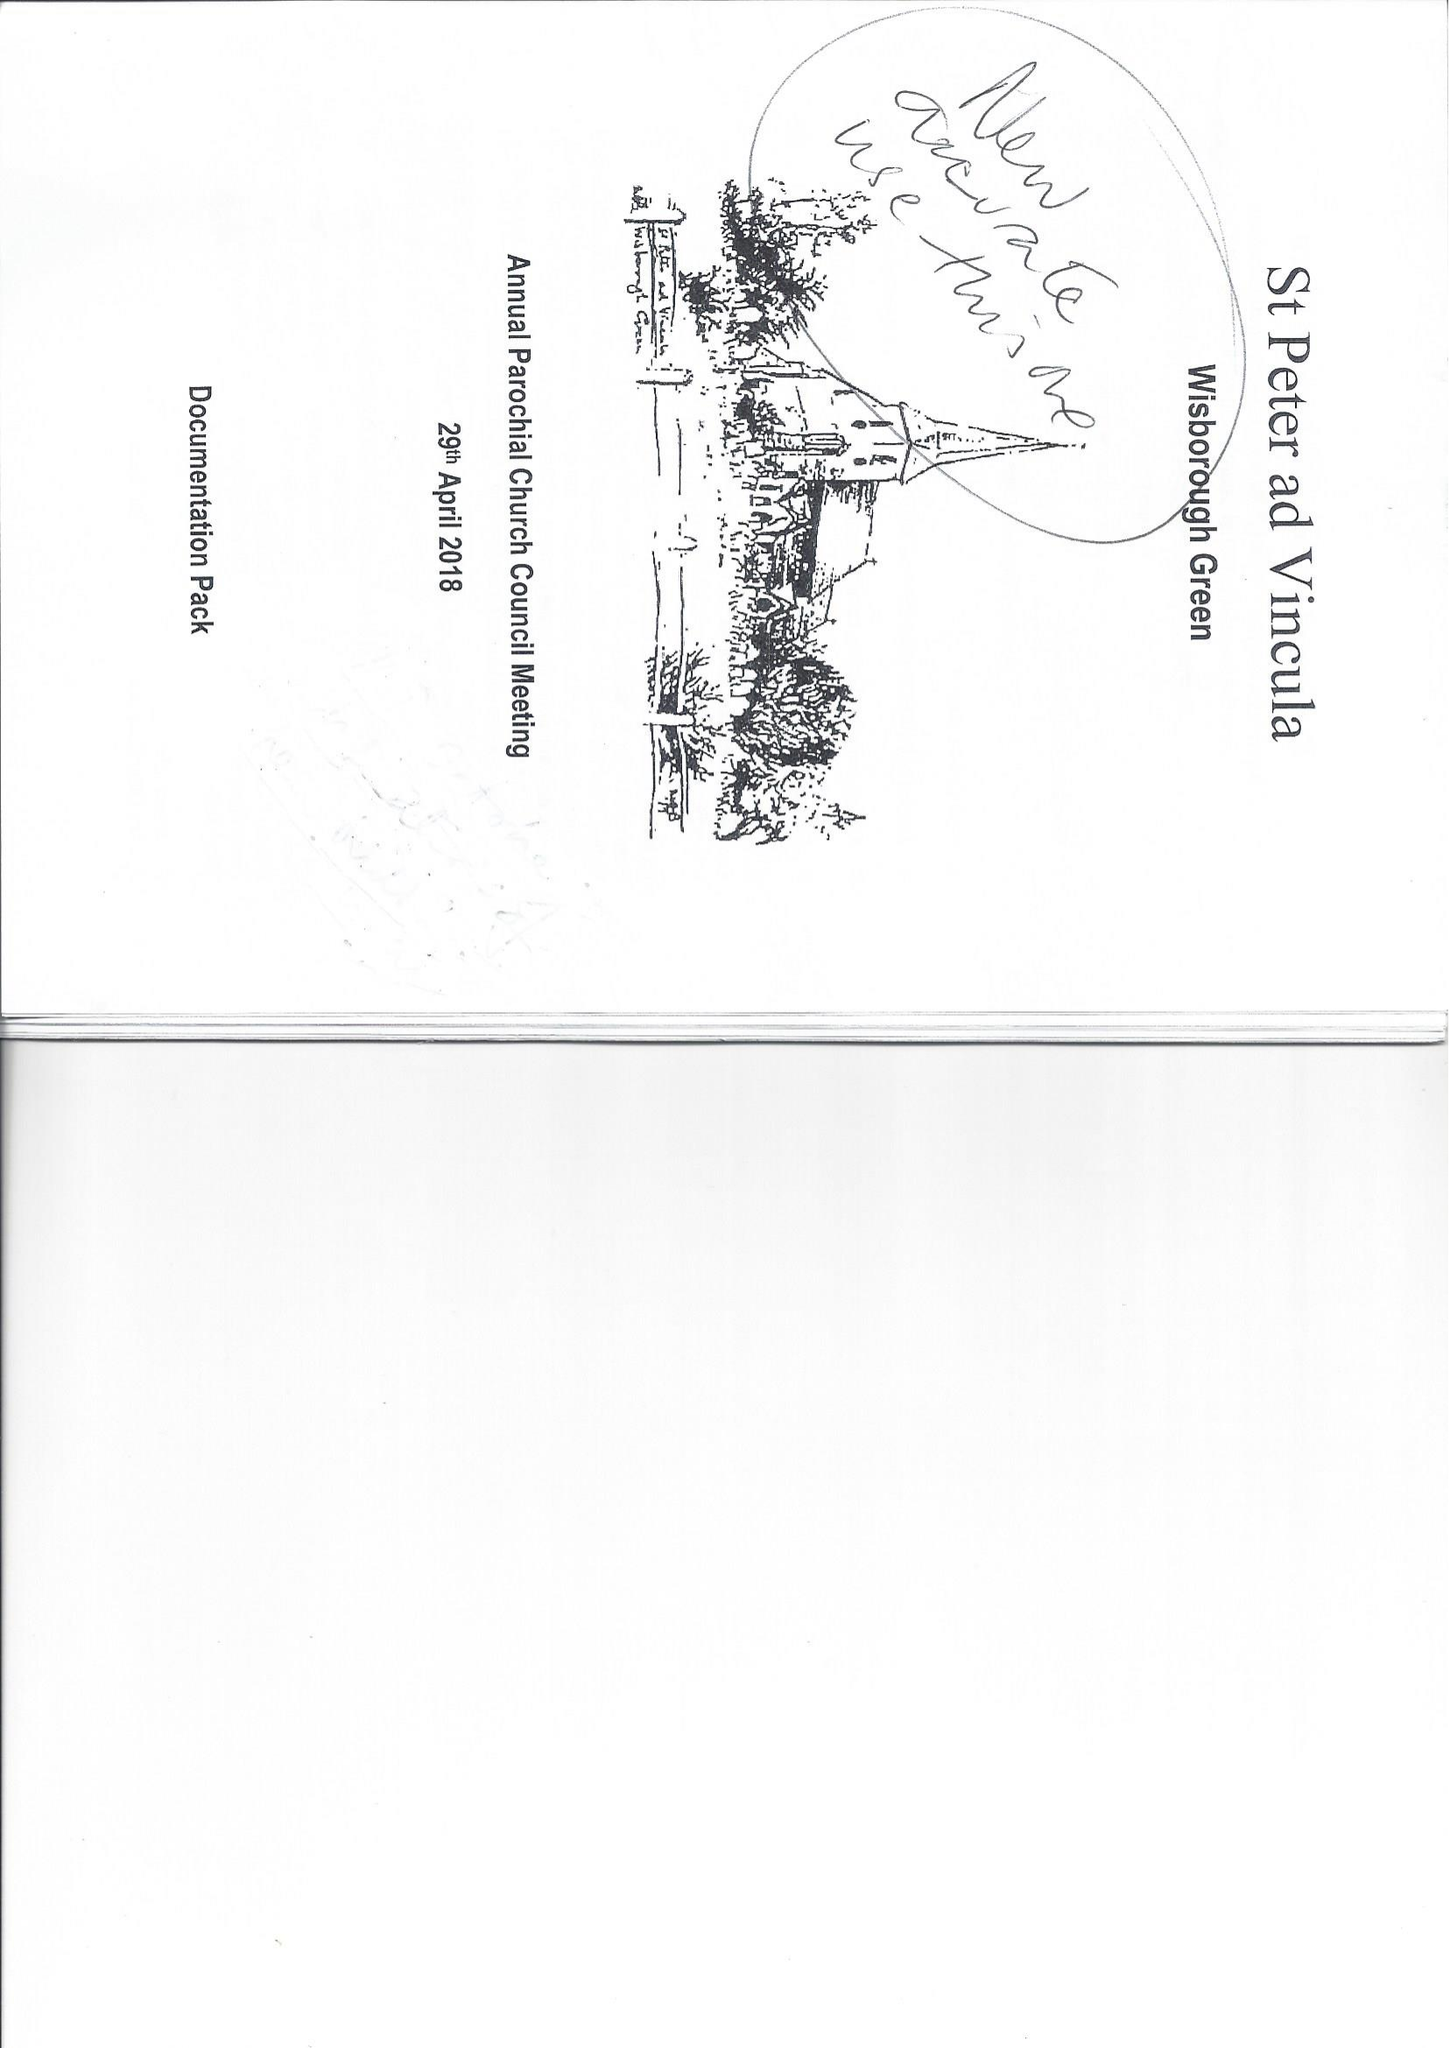What is the value for the income_annually_in_british_pounds?
Answer the question using a single word or phrase. 121467.00 